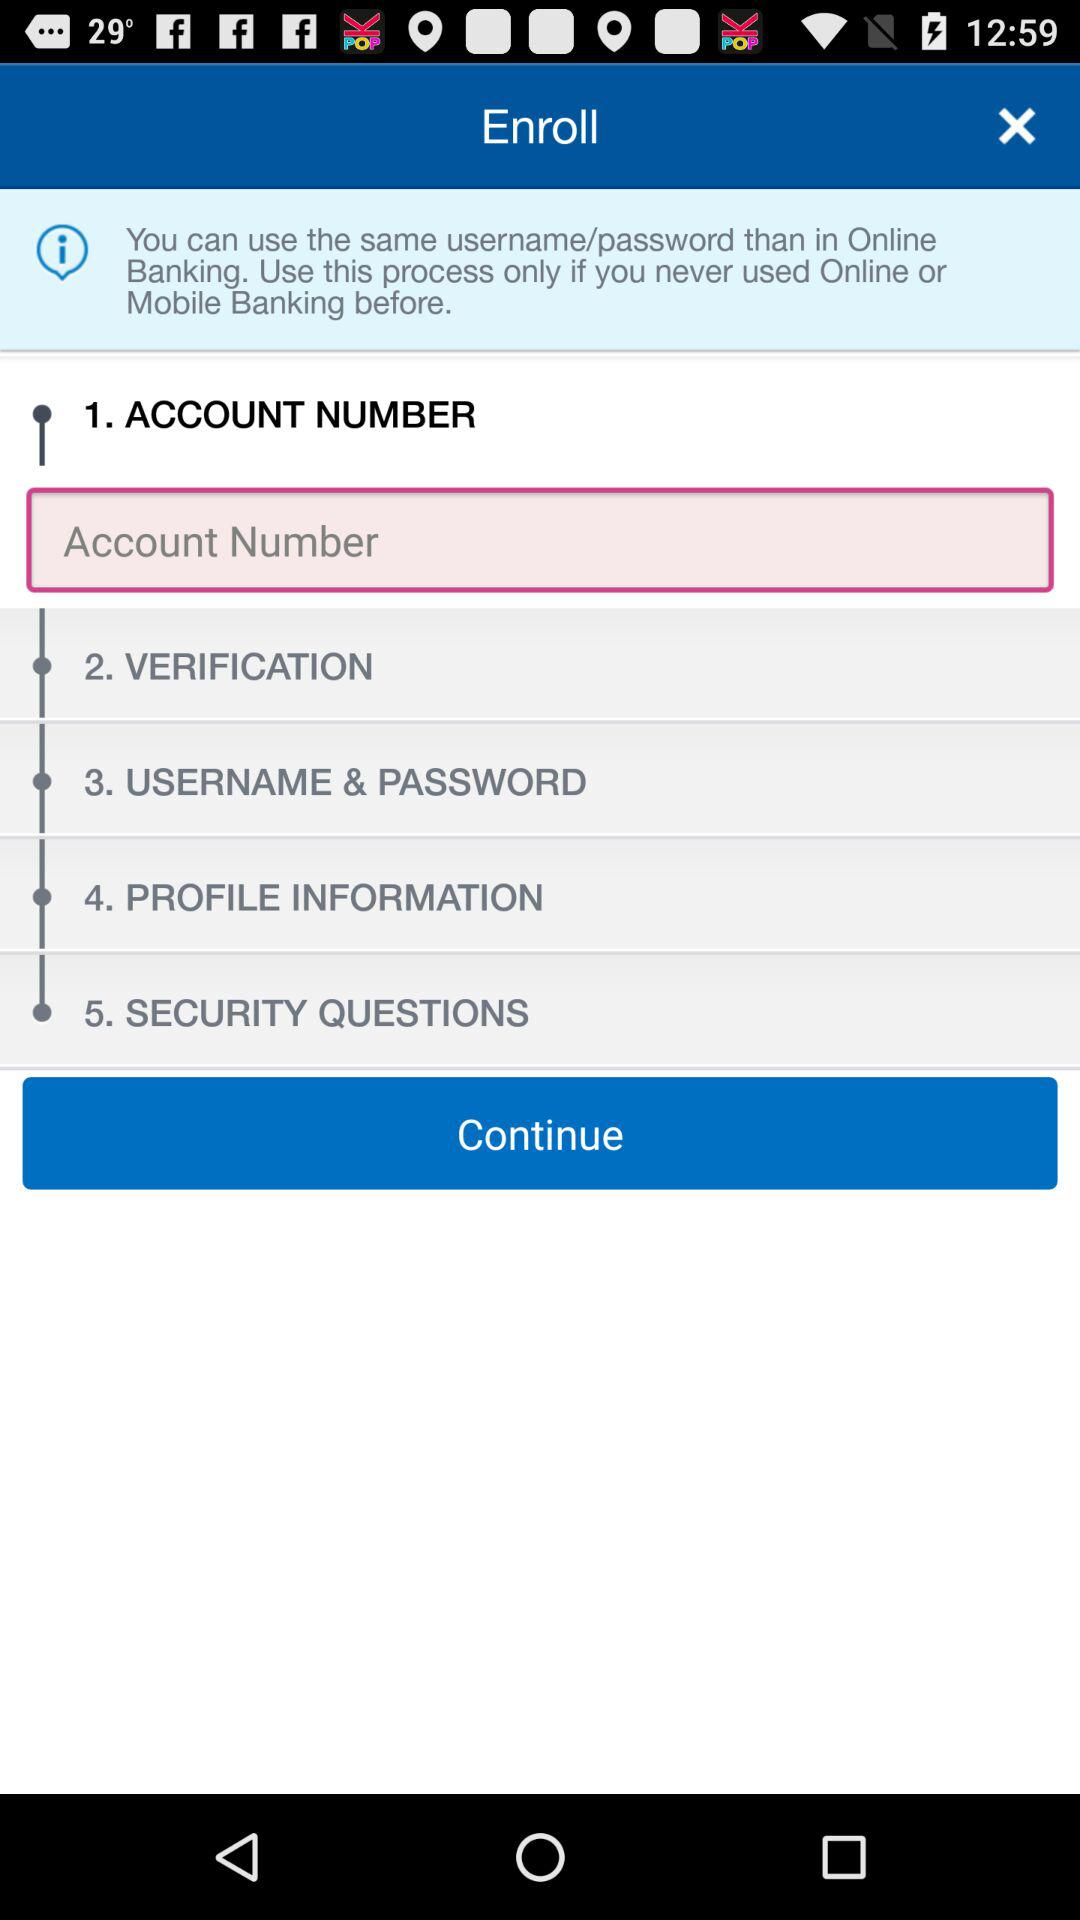What is the selected option? The selected option is "Account Number". 